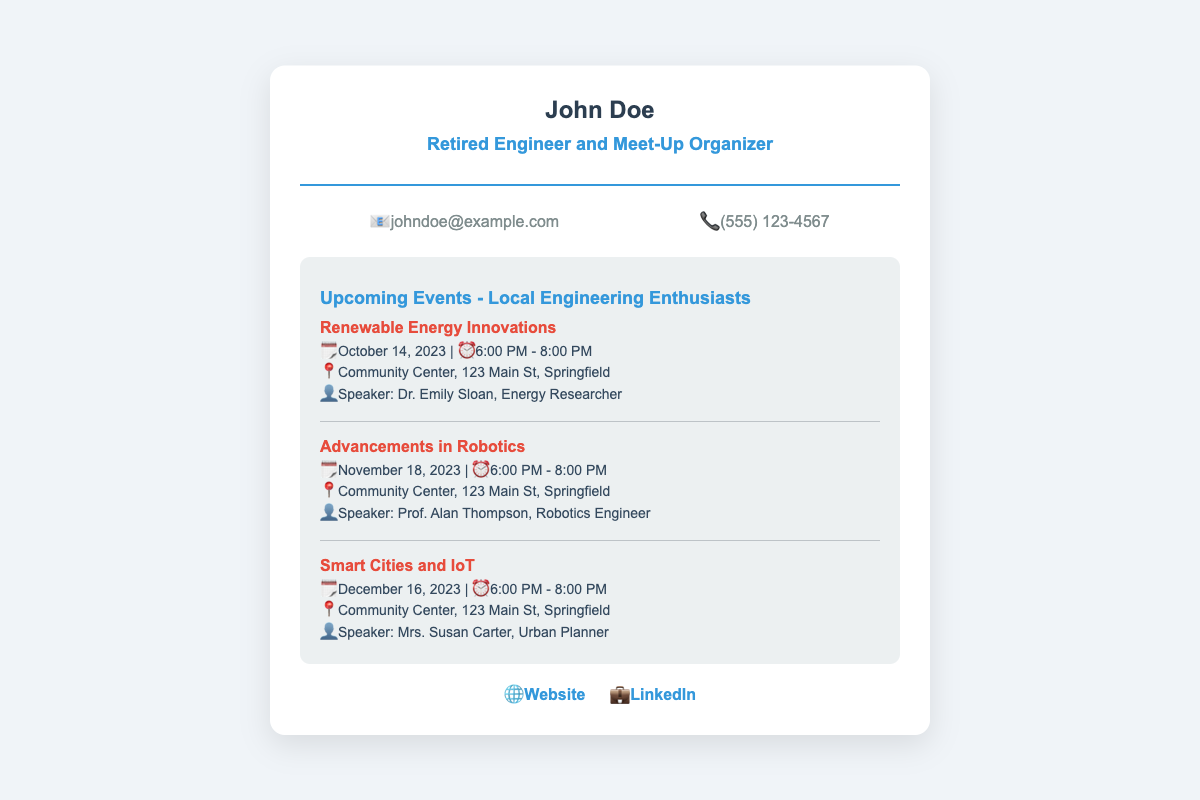What is the name of the organizer? The organizer's name is prominently displayed at the top of the card.
Answer: John Doe What is the email address provided? The email address can be found in the contact information section of the card.
Answer: johndoe@example.com What is the phone number listed? The phone number is also found in the contact information section of the card.
Answer: (555) 123-4567 When is the event "Renewable Energy Innovations" scheduled? The date for the first event is mentioned clearly in the events section.
Answer: October 14, 2023 Who is the speaker for the "Advancements in Robotics" event? The speaker's name is provided for each event listed.
Answer: Prof. Alan Thompson Where will the events take place? The location for all the events is mentioned in the event descriptions.
Answer: Community Center, 123 Main St, Springfield How many events are listed on the card? By counting the events mentioned in the events section, we can derive this number.
Answer: Three What is the website link given? The website link is included in the social links section of the card.
Answer: www.localengineeringenthusiasts.org What is the topic of the last event scheduled? The last event's topic can be found within the event descriptions.
Answer: Smart Cities and IoT 